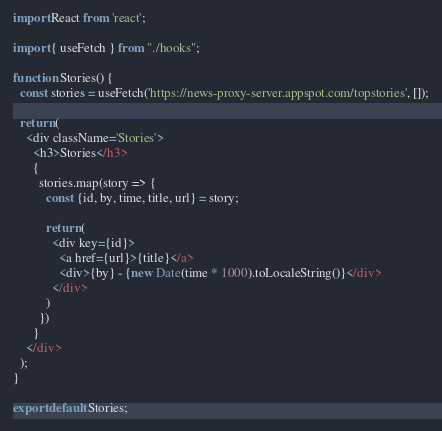Convert code to text. <code><loc_0><loc_0><loc_500><loc_500><_JavaScript_>import React from 'react';

import { useFetch } from "./hooks";

function Stories() {
  const stories = useFetch('https://news-proxy-server.appspot.com/topstories', []);

  return (
    <div className='Stories'>
      <h3>Stories</h3>
      {
        stories.map(story => {
          const {id, by, time, title, url} = story;

          return (
            <div key={id}>
              <a href={url}>{title}</a>
              <div>{by} - {new Date(time * 1000).toLocaleString()}</div>
            </div>
          )
        })
      }
    </div>
  );
}

export default Stories;
</code> 